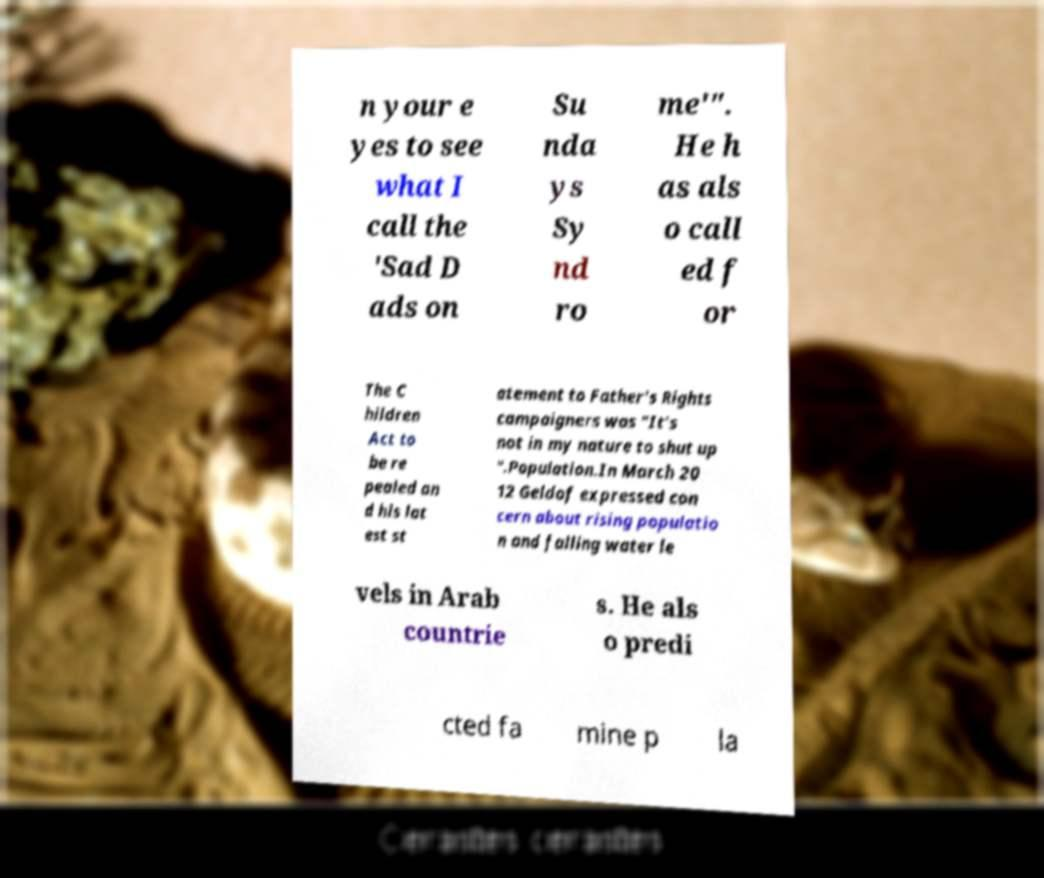Could you extract and type out the text from this image? n your e yes to see what I call the 'Sad D ads on Su nda ys Sy nd ro me'". He h as als o call ed f or The C hildren Act to be re pealed an d his lat est st atement to Father's Rights campaigners was "It's not in my nature to shut up ".Population.In March 20 12 Geldof expressed con cern about rising populatio n and falling water le vels in Arab countrie s. He als o predi cted fa mine p la 